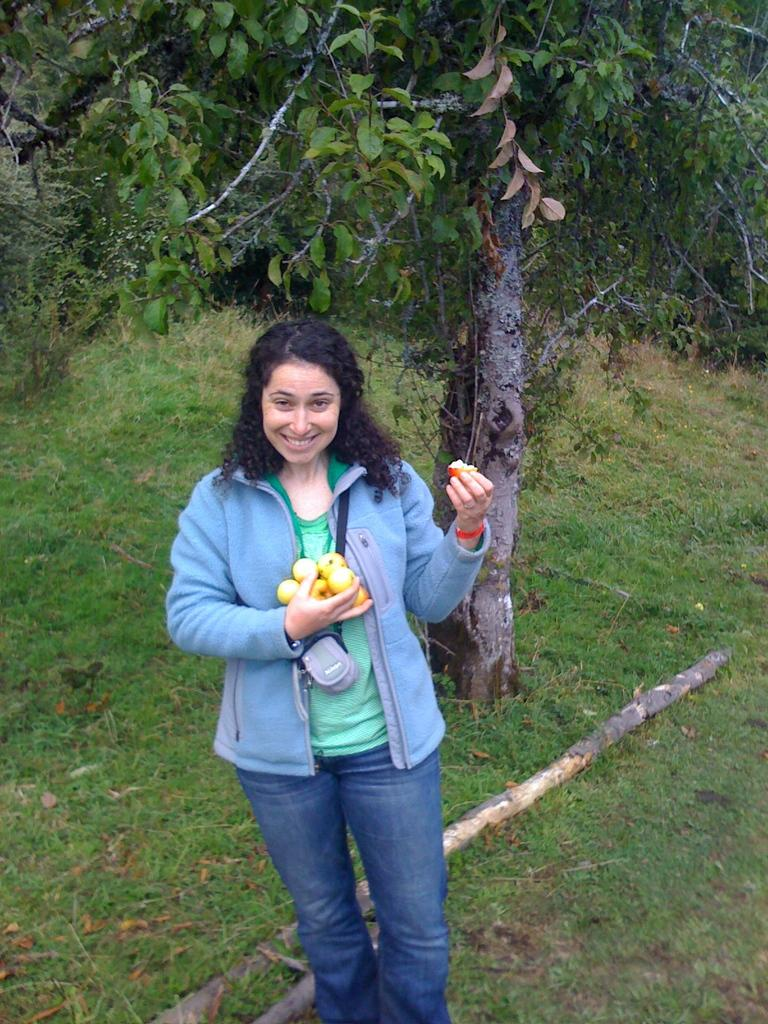Who is the main subject in the image? There is a girl in the center of the image. What is the girl holding in her hands? The girl is holding fruits in her hands. What can be seen in the background of the image? There is greenery in the background of the image. What type of meal is being prepared on the girl's toes in the image? There is no meal being prepared on the girl's toes in the image, as her feet are not visible. 